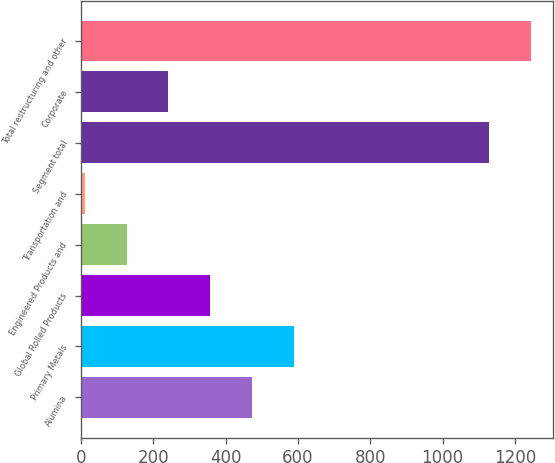<chart> <loc_0><loc_0><loc_500><loc_500><bar_chart><fcel>Alumina<fcel>Primary Metals<fcel>Global Rolled Products<fcel>Engineered Products and<fcel>Transportation and<fcel>Segment total<fcel>Corporate<fcel>Total restructuring and other<nl><fcel>473.2<fcel>589<fcel>357.4<fcel>125.8<fcel>10<fcel>1129<fcel>241.6<fcel>1244.8<nl></chart> 